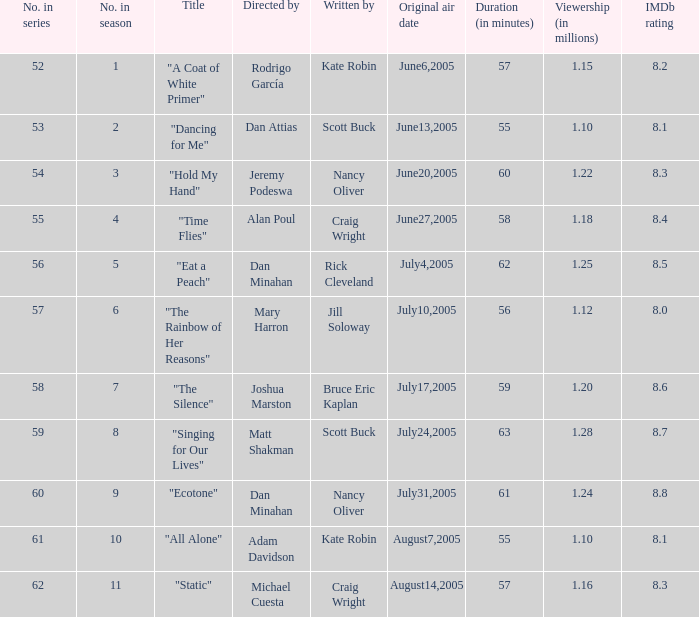What s the episode number in the season that was written by Nancy Oliver? 9.0. 